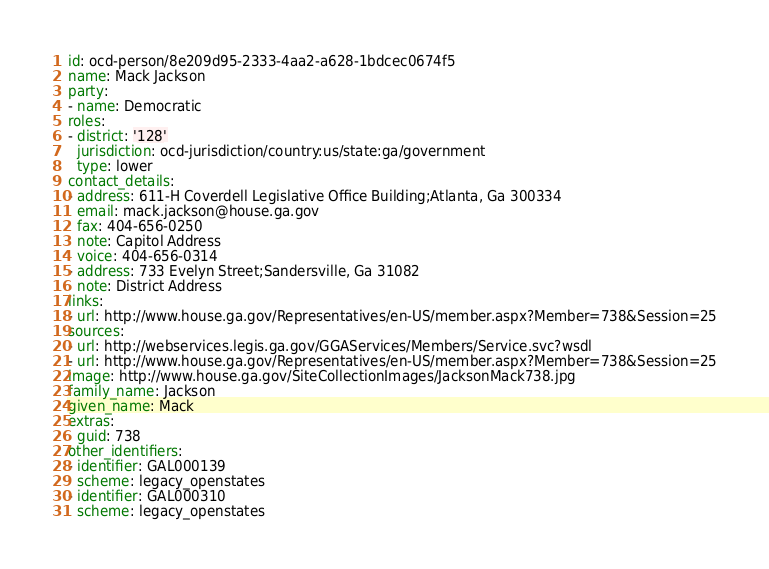<code> <loc_0><loc_0><loc_500><loc_500><_YAML_>id: ocd-person/8e209d95-2333-4aa2-a628-1bdcec0674f5
name: Mack Jackson
party:
- name: Democratic
roles:
- district: '128'
  jurisdiction: ocd-jurisdiction/country:us/state:ga/government
  type: lower
contact_details:
- address: 611-H Coverdell Legislative Office Building;Atlanta, Ga 300334
  email: mack.jackson@house.ga.gov
  fax: 404-656-0250
  note: Capitol Address
  voice: 404-656-0314
- address: 733 Evelyn Street;Sandersville, Ga 31082
  note: District Address
links:
- url: http://www.house.ga.gov/Representatives/en-US/member.aspx?Member=738&Session=25
sources:
- url: http://webservices.legis.ga.gov/GGAServices/Members/Service.svc?wsdl
- url: http://www.house.ga.gov/Representatives/en-US/member.aspx?Member=738&Session=25
image: http://www.house.ga.gov/SiteCollectionImages/JacksonMack738.jpg
family_name: Jackson
given_name: Mack
extras:
  guid: 738
other_identifiers:
- identifier: GAL000139
  scheme: legacy_openstates
- identifier: GAL000310
  scheme: legacy_openstates
</code> 